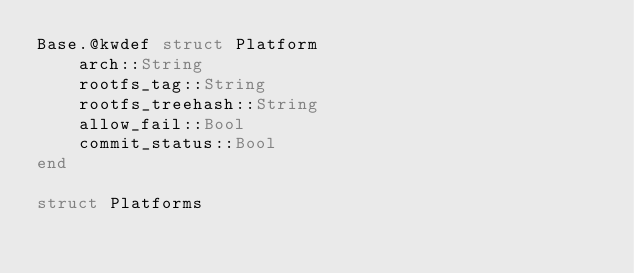<code> <loc_0><loc_0><loc_500><loc_500><_Julia_>Base.@kwdef struct Platform
    arch::String
    rootfs_tag::String
    rootfs_treehash::String
    allow_fail::Bool
    commit_status::Bool
end

struct Platforms</code> 